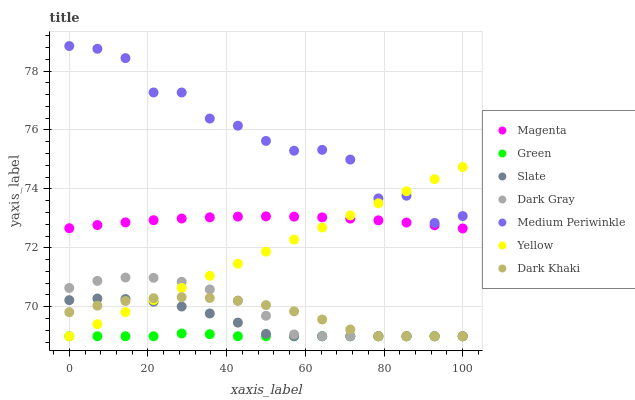Does Green have the minimum area under the curve?
Answer yes or no. Yes. Does Medium Periwinkle have the maximum area under the curve?
Answer yes or no. Yes. Does Slate have the minimum area under the curve?
Answer yes or no. No. Does Slate have the maximum area under the curve?
Answer yes or no. No. Is Yellow the smoothest?
Answer yes or no. Yes. Is Medium Periwinkle the roughest?
Answer yes or no. Yes. Is Slate the smoothest?
Answer yes or no. No. Is Slate the roughest?
Answer yes or no. No. Does Dark Khaki have the lowest value?
Answer yes or no. Yes. Does Medium Periwinkle have the lowest value?
Answer yes or no. No. Does Medium Periwinkle have the highest value?
Answer yes or no. Yes. Does Slate have the highest value?
Answer yes or no. No. Is Dark Gray less than Medium Periwinkle?
Answer yes or no. Yes. Is Medium Periwinkle greater than Dark Gray?
Answer yes or no. Yes. Does Green intersect Yellow?
Answer yes or no. Yes. Is Green less than Yellow?
Answer yes or no. No. Is Green greater than Yellow?
Answer yes or no. No. Does Dark Gray intersect Medium Periwinkle?
Answer yes or no. No. 